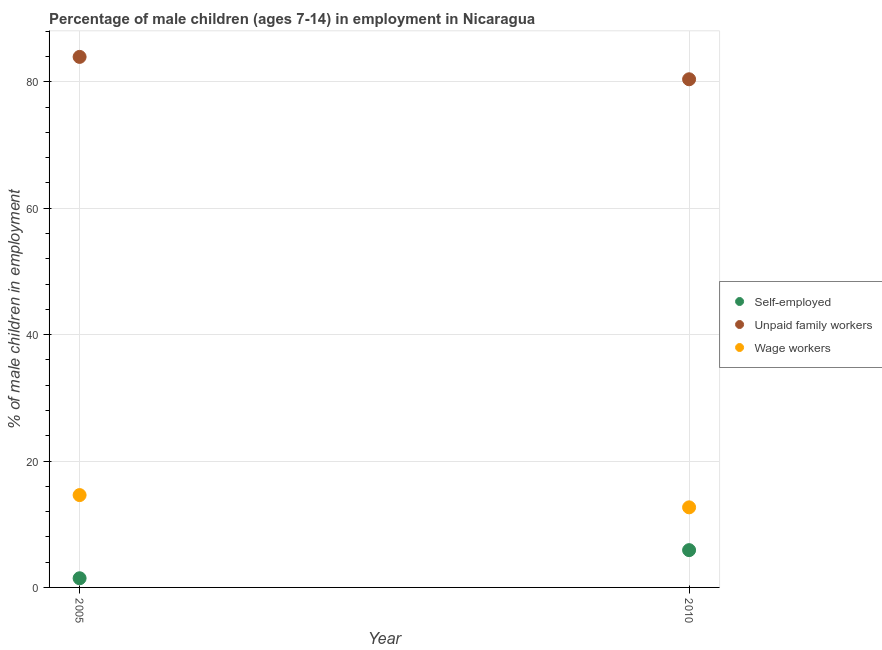What is the percentage of children employed as wage workers in 2005?
Your response must be concise. 14.61. Across all years, what is the minimum percentage of self employed children?
Your answer should be compact. 1.45. In which year was the percentage of children employed as unpaid family workers maximum?
Provide a short and direct response. 2005. In which year was the percentage of children employed as unpaid family workers minimum?
Make the answer very short. 2010. What is the total percentage of children employed as unpaid family workers in the graph?
Your response must be concise. 164.34. What is the difference between the percentage of self employed children in 2005 and that in 2010?
Keep it short and to the point. -4.45. What is the difference between the percentage of self employed children in 2010 and the percentage of children employed as wage workers in 2005?
Offer a terse response. -8.71. What is the average percentage of children employed as unpaid family workers per year?
Provide a succinct answer. 82.17. In the year 2005, what is the difference between the percentage of children employed as wage workers and percentage of children employed as unpaid family workers?
Offer a terse response. -69.33. What is the ratio of the percentage of children employed as wage workers in 2005 to that in 2010?
Your answer should be very brief. 1.15. Is it the case that in every year, the sum of the percentage of self employed children and percentage of children employed as unpaid family workers is greater than the percentage of children employed as wage workers?
Your answer should be very brief. Yes. Does the graph contain any zero values?
Your answer should be very brief. No. Where does the legend appear in the graph?
Offer a very short reply. Center right. What is the title of the graph?
Ensure brevity in your answer.  Percentage of male children (ages 7-14) in employment in Nicaragua. Does "Tertiary education" appear as one of the legend labels in the graph?
Keep it short and to the point. No. What is the label or title of the Y-axis?
Your answer should be compact. % of male children in employment. What is the % of male children in employment of Self-employed in 2005?
Offer a very short reply. 1.45. What is the % of male children in employment in Unpaid family workers in 2005?
Ensure brevity in your answer.  83.94. What is the % of male children in employment of Wage workers in 2005?
Keep it short and to the point. 14.61. What is the % of male children in employment of Unpaid family workers in 2010?
Offer a terse response. 80.4. What is the % of male children in employment in Wage workers in 2010?
Your answer should be very brief. 12.67. Across all years, what is the maximum % of male children in employment in Self-employed?
Your answer should be very brief. 5.9. Across all years, what is the maximum % of male children in employment in Unpaid family workers?
Provide a succinct answer. 83.94. Across all years, what is the maximum % of male children in employment of Wage workers?
Offer a very short reply. 14.61. Across all years, what is the minimum % of male children in employment of Self-employed?
Your response must be concise. 1.45. Across all years, what is the minimum % of male children in employment of Unpaid family workers?
Your response must be concise. 80.4. Across all years, what is the minimum % of male children in employment in Wage workers?
Keep it short and to the point. 12.67. What is the total % of male children in employment in Self-employed in the graph?
Keep it short and to the point. 7.35. What is the total % of male children in employment in Unpaid family workers in the graph?
Offer a terse response. 164.34. What is the total % of male children in employment in Wage workers in the graph?
Your answer should be very brief. 27.28. What is the difference between the % of male children in employment in Self-employed in 2005 and that in 2010?
Make the answer very short. -4.45. What is the difference between the % of male children in employment of Unpaid family workers in 2005 and that in 2010?
Provide a short and direct response. 3.54. What is the difference between the % of male children in employment in Wage workers in 2005 and that in 2010?
Give a very brief answer. 1.94. What is the difference between the % of male children in employment in Self-employed in 2005 and the % of male children in employment in Unpaid family workers in 2010?
Provide a short and direct response. -78.95. What is the difference between the % of male children in employment in Self-employed in 2005 and the % of male children in employment in Wage workers in 2010?
Provide a succinct answer. -11.22. What is the difference between the % of male children in employment of Unpaid family workers in 2005 and the % of male children in employment of Wage workers in 2010?
Your response must be concise. 71.27. What is the average % of male children in employment in Self-employed per year?
Your answer should be very brief. 3.67. What is the average % of male children in employment of Unpaid family workers per year?
Your answer should be very brief. 82.17. What is the average % of male children in employment in Wage workers per year?
Ensure brevity in your answer.  13.64. In the year 2005, what is the difference between the % of male children in employment in Self-employed and % of male children in employment in Unpaid family workers?
Provide a succinct answer. -82.49. In the year 2005, what is the difference between the % of male children in employment of Self-employed and % of male children in employment of Wage workers?
Offer a very short reply. -13.16. In the year 2005, what is the difference between the % of male children in employment of Unpaid family workers and % of male children in employment of Wage workers?
Your answer should be very brief. 69.33. In the year 2010, what is the difference between the % of male children in employment in Self-employed and % of male children in employment in Unpaid family workers?
Provide a succinct answer. -74.5. In the year 2010, what is the difference between the % of male children in employment in Self-employed and % of male children in employment in Wage workers?
Provide a succinct answer. -6.77. In the year 2010, what is the difference between the % of male children in employment of Unpaid family workers and % of male children in employment of Wage workers?
Your answer should be compact. 67.73. What is the ratio of the % of male children in employment in Self-employed in 2005 to that in 2010?
Offer a very short reply. 0.25. What is the ratio of the % of male children in employment in Unpaid family workers in 2005 to that in 2010?
Your response must be concise. 1.04. What is the ratio of the % of male children in employment of Wage workers in 2005 to that in 2010?
Your answer should be compact. 1.15. What is the difference between the highest and the second highest % of male children in employment in Self-employed?
Keep it short and to the point. 4.45. What is the difference between the highest and the second highest % of male children in employment in Unpaid family workers?
Provide a succinct answer. 3.54. What is the difference between the highest and the second highest % of male children in employment in Wage workers?
Give a very brief answer. 1.94. What is the difference between the highest and the lowest % of male children in employment in Self-employed?
Provide a short and direct response. 4.45. What is the difference between the highest and the lowest % of male children in employment of Unpaid family workers?
Give a very brief answer. 3.54. What is the difference between the highest and the lowest % of male children in employment of Wage workers?
Provide a succinct answer. 1.94. 